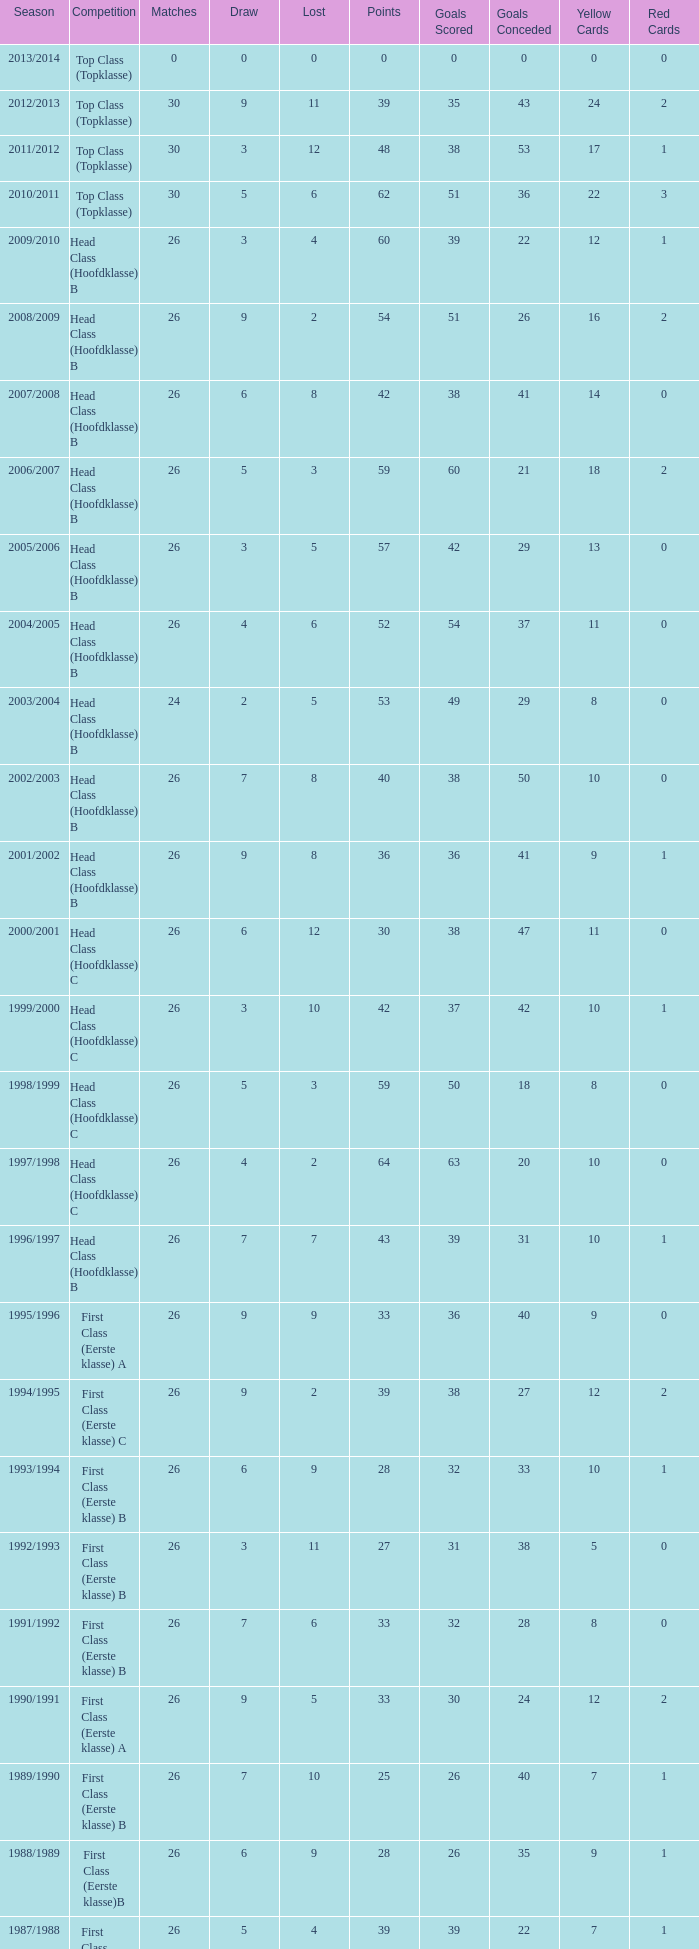What is the sum of the losses that a match score larger than 26, a points score of 62, and a draw greater than 5? None. 